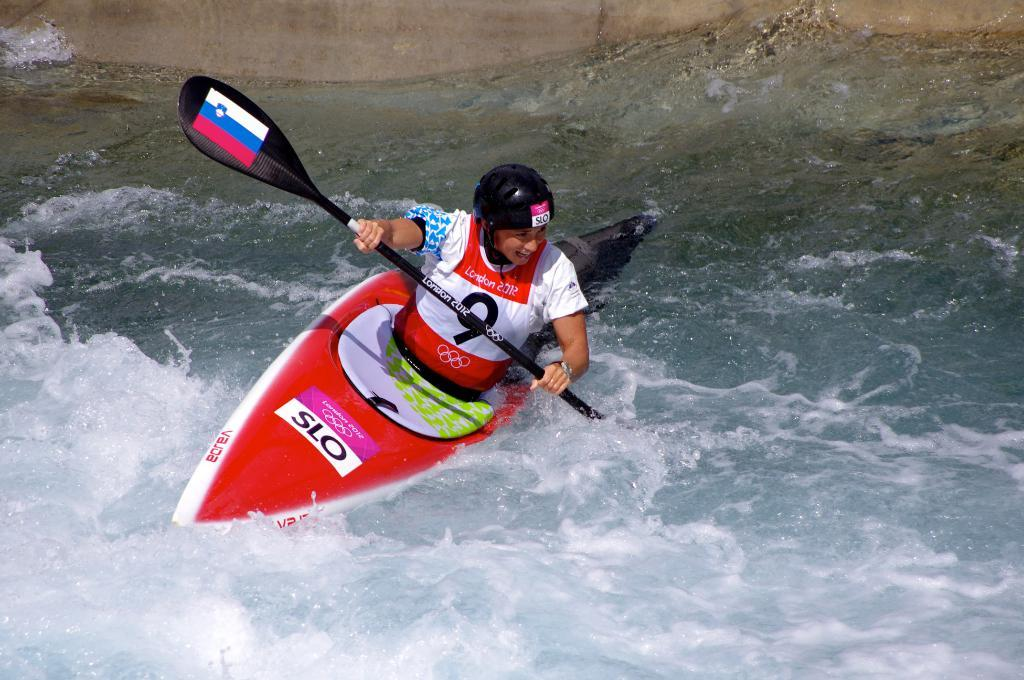What activity is the woman in the image engaged in? The woman is kayaking in the water. What is the woman using to propel the kayak? The woman is holding a paddle. What can be seen in the background of the image? There is a wall visible in the background. What type of straw is the woman using to sleep in the image? There is no straw or indication of sleeping in the image; the woman is kayaking in the water. 